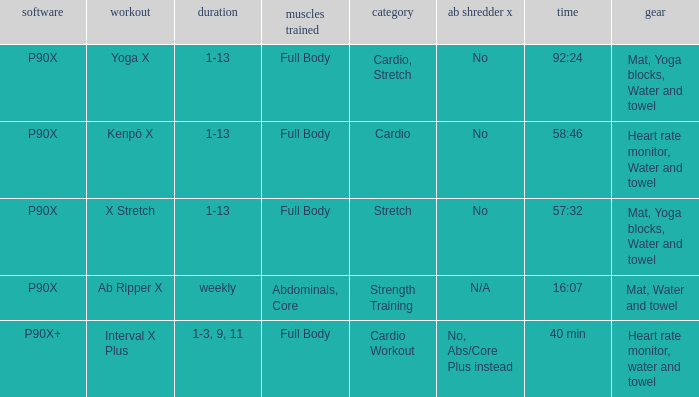Can you parse all the data within this table? {'header': ['software', 'workout', 'duration', 'muscles trained', 'category', 'ab shredder x', 'time', 'gear'], 'rows': [['P90X', 'Yoga X', '1-13', 'Full Body', 'Cardio, Stretch', 'No', '92:24', 'Mat, Yoga blocks, Water and towel'], ['P90X', 'Kenpō X', '1-13', 'Full Body', 'Cardio', 'No', '58:46', 'Heart rate monitor, Water and towel'], ['P90X', 'X Stretch', '1-13', 'Full Body', 'Stretch', 'No', '57:32', 'Mat, Yoga blocks, Water and towel'], ['P90X', 'Ab Ripper X', 'weekly', 'Abdominals, Core', 'Strength Training', 'N/A', '16:07', 'Mat, Water and towel'], ['P90X+', 'Interval X Plus', '1-3, 9, 11', 'Full Body', 'Cardio Workout', 'No, Abs/Core Plus instead', '40 min', 'Heart rate monitor, water and towel']]} What is the week when type is cardio workout? 1-3, 9, 11. 